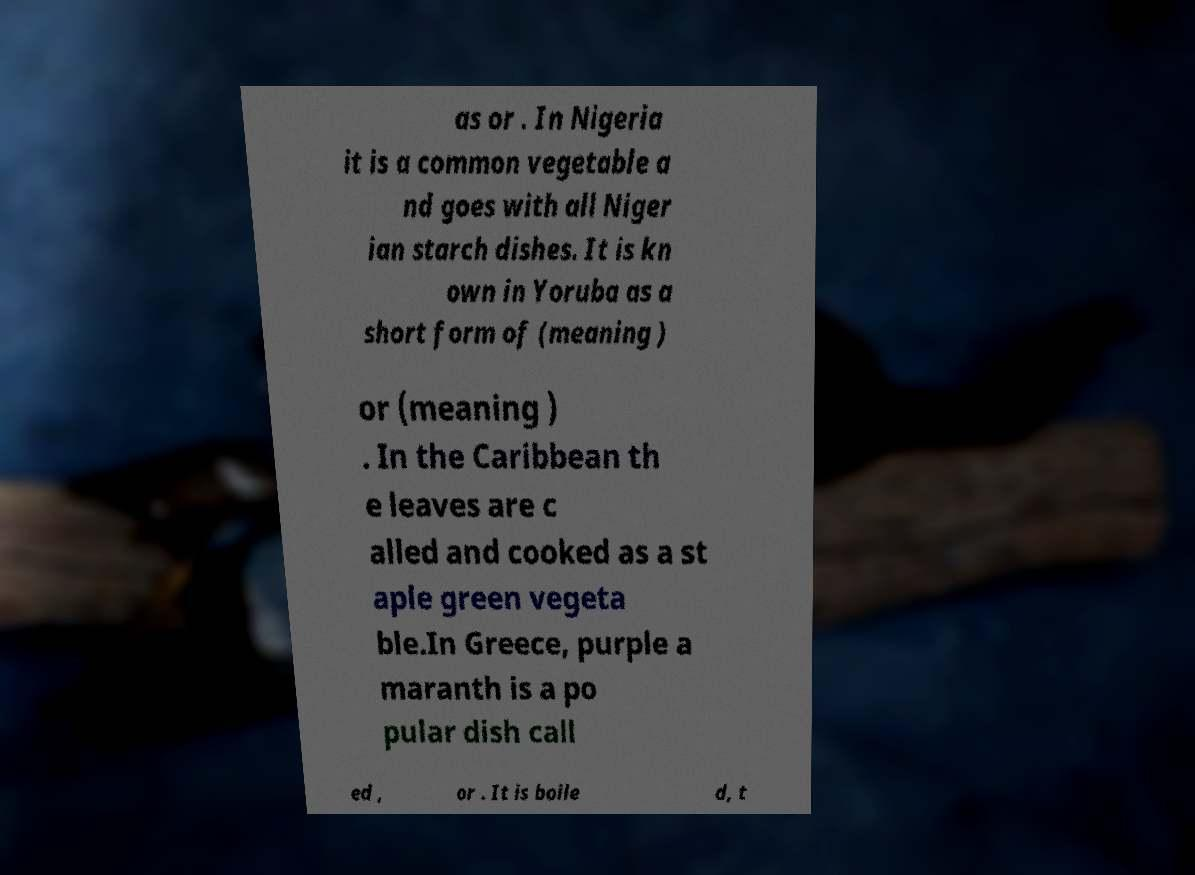There's text embedded in this image that I need extracted. Can you transcribe it verbatim? as or . In Nigeria it is a common vegetable a nd goes with all Niger ian starch dishes. It is kn own in Yoruba as a short form of (meaning ) or (meaning ) . In the Caribbean th e leaves are c alled and cooked as a st aple green vegeta ble.In Greece, purple a maranth is a po pular dish call ed , or . It is boile d, t 